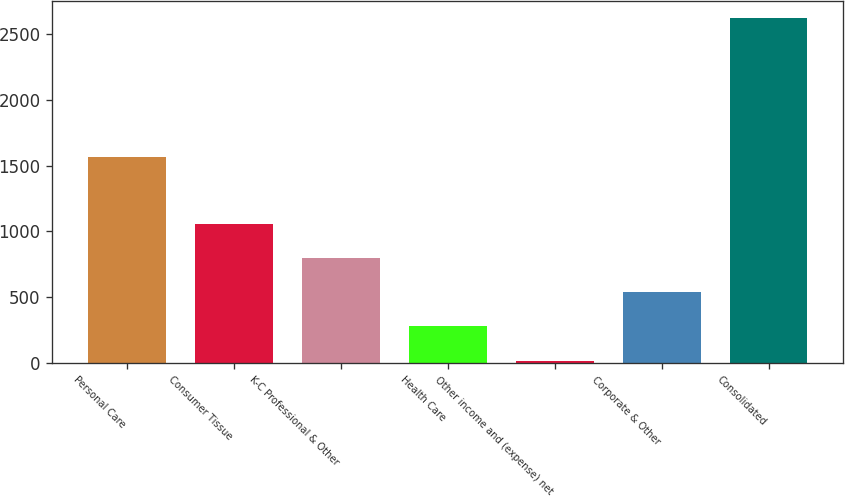Convert chart to OTSL. <chart><loc_0><loc_0><loc_500><loc_500><bar_chart><fcel>Personal Care<fcel>Consumer Tissue<fcel>K-C Professional & Other<fcel>Health Care<fcel>Other income and (expense) net<fcel>Corporate & Other<fcel>Consolidated<nl><fcel>1562.4<fcel>1057.6<fcel>797.8<fcel>278.2<fcel>18.4<fcel>538<fcel>2616.4<nl></chart> 